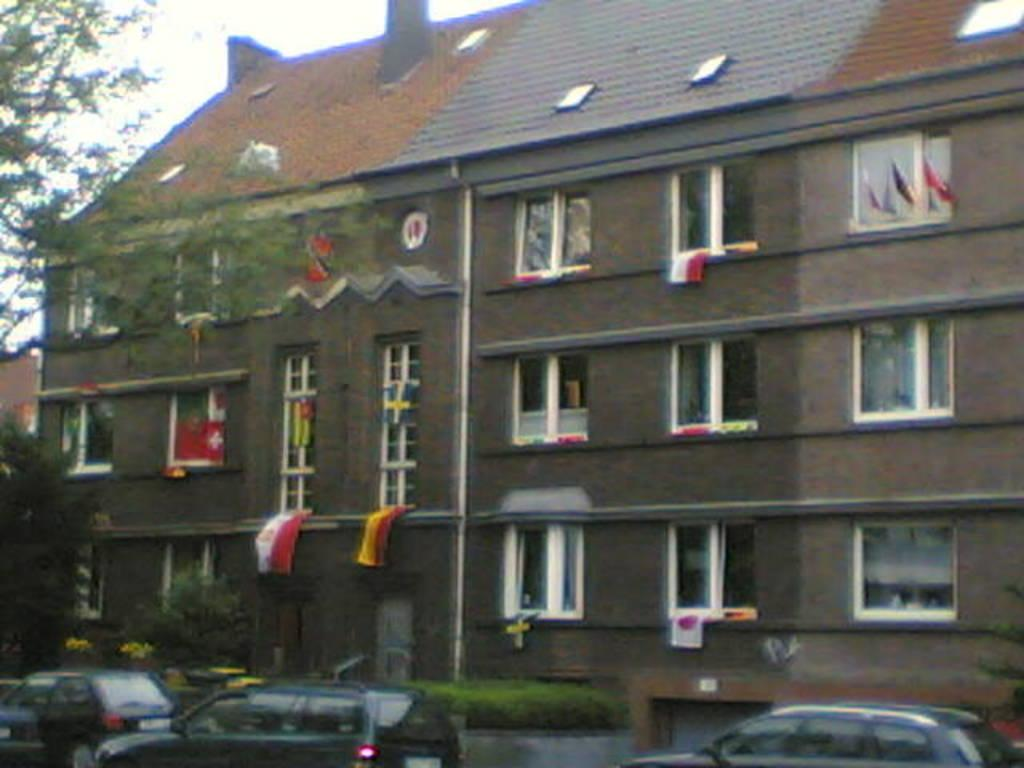What type of structure is visible in the image? There is a building with windows in the image. What decorations are on the building? There are flags on the building. What vehicles are in front of the building? There are cars in front of the building. What type of vegetation is in front of the building? There are bushes and trees in front of the building. What direction is the map pointing towards in the image? There is no map present in the image, so it is not possible to determine the direction it might be pointing. 